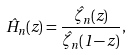<formula> <loc_0><loc_0><loc_500><loc_500>\hat { H } _ { n } ( z ) = \frac { \hat { \zeta } _ { n } ( z ) } { \hat { \zeta } _ { n } ( 1 - z ) } ,</formula> 